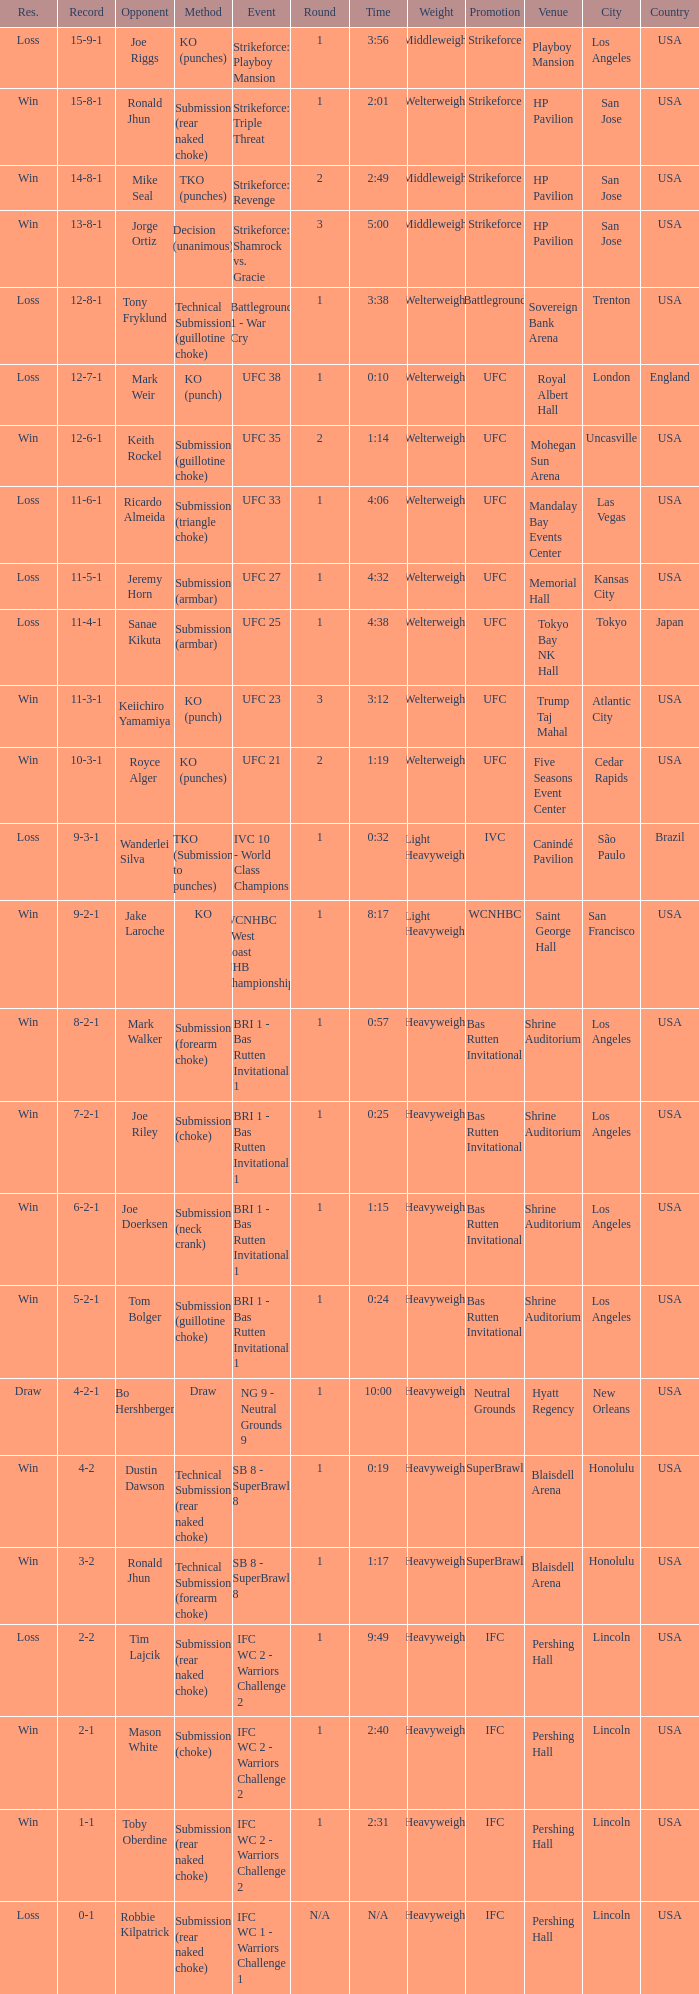Who was the opponent when the fight had a time of 0:10? Mark Weir. 